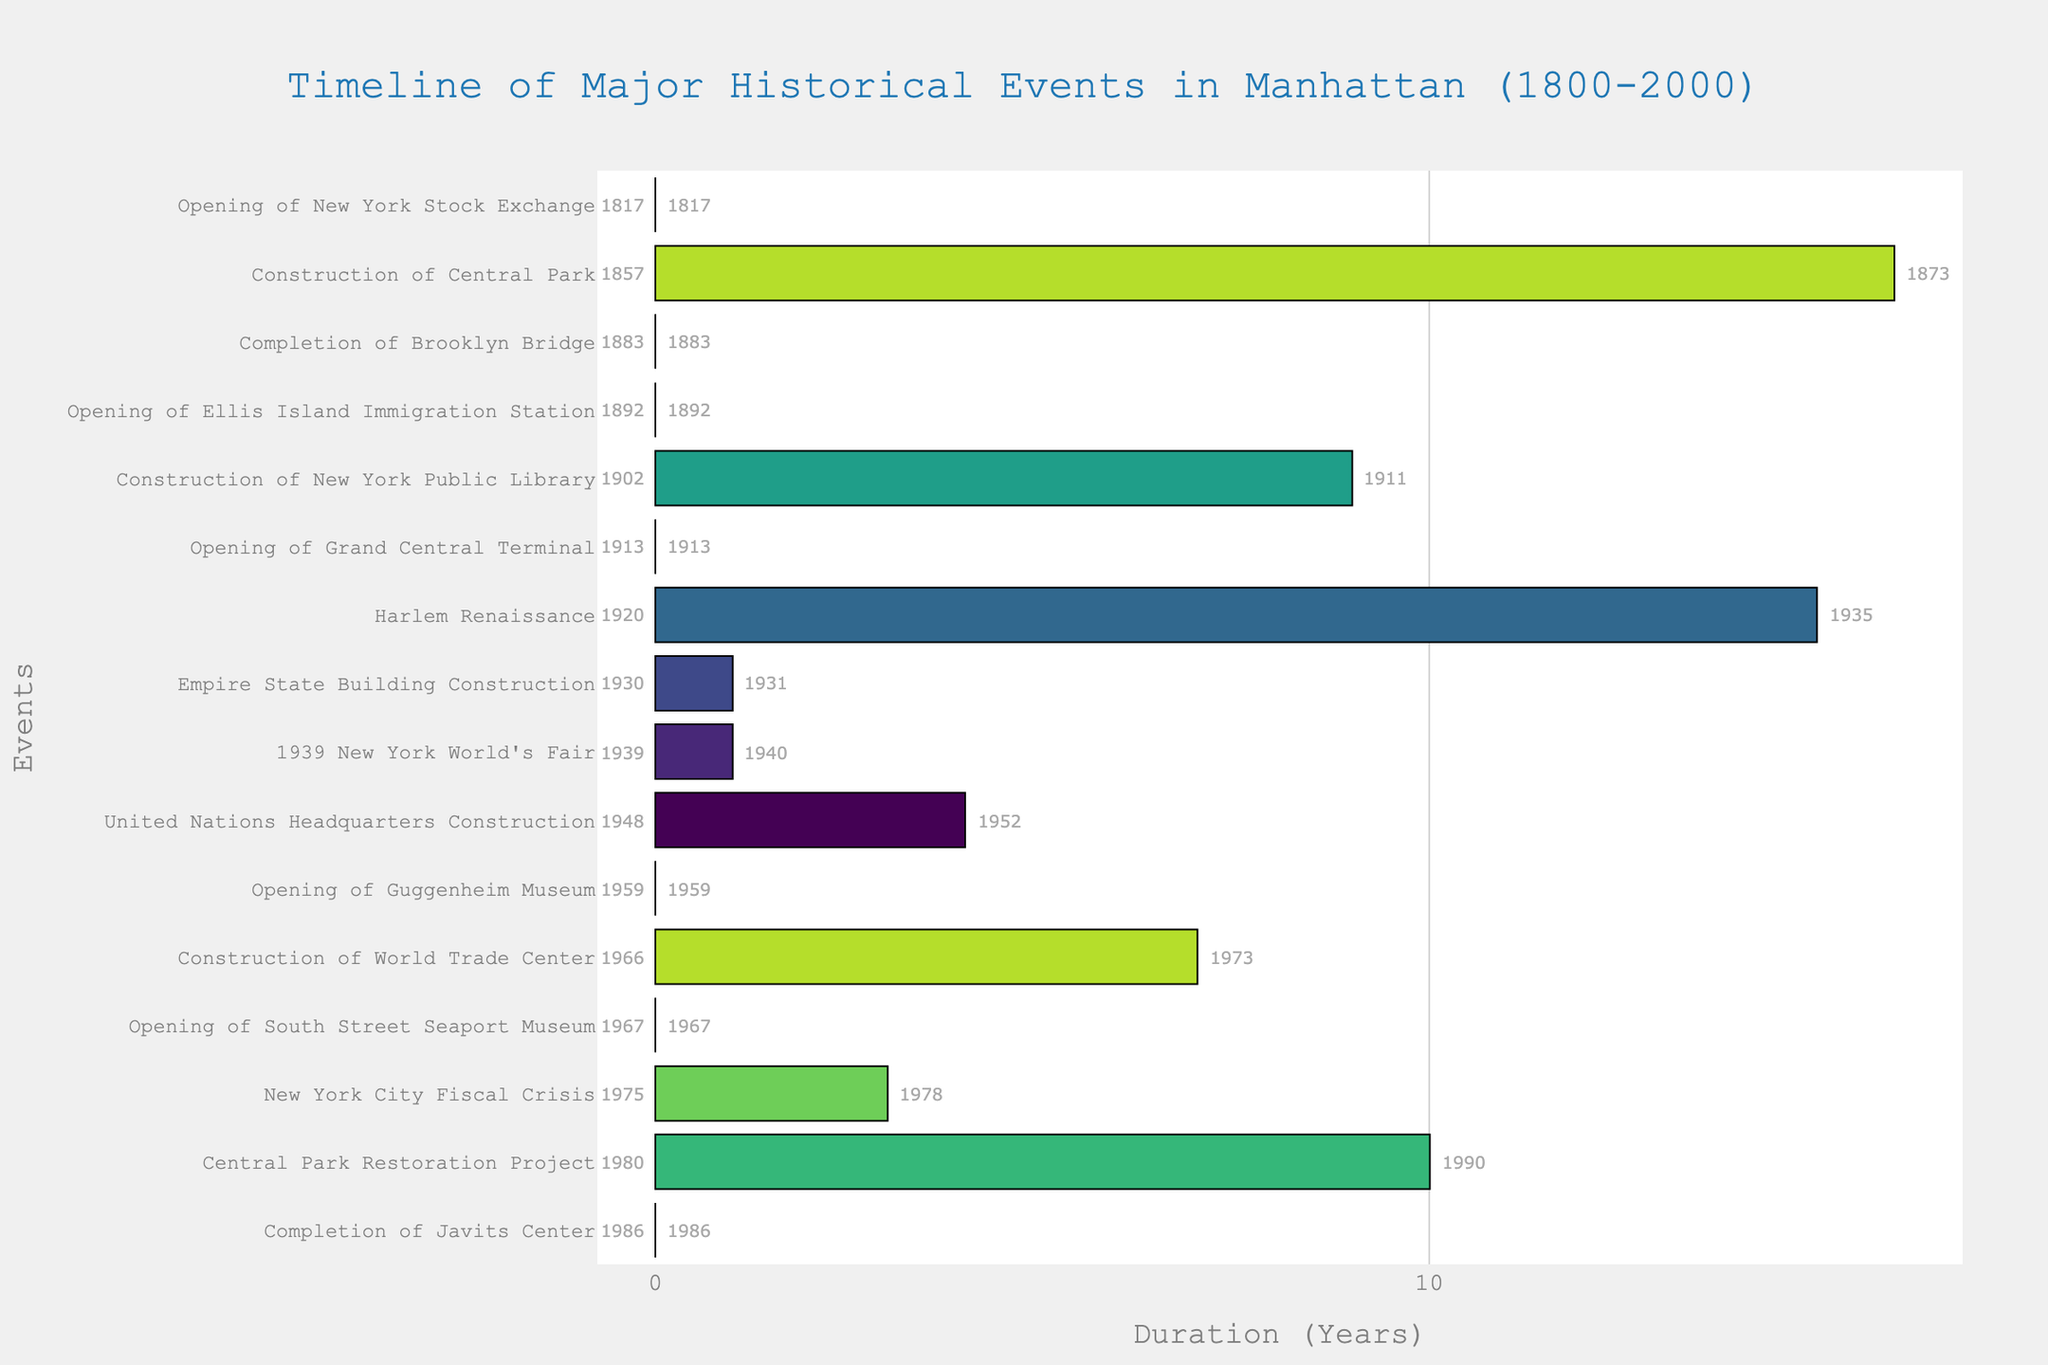Which event began the timeline of major historical events in Manhattan? The first event on the timeline is the one with the earliest "Start" year. In this Gantt Chart, it's the "Opening of New York Stock Exchange" which starts in 1817.
Answer: Opening of New York Stock Exchange How many years did the Construction of Central Park take? To find the duration, subtract the "Start" year from the "End" year. For Central Park, it's from 1857 to 1873, so 1873 - 1857 = 16 years.
Answer: 16 years Which event lasted longest, and how long did it last? To determine the longest event, locate the event with the longest bar. The Central Park Restoration Project, from 1980 to 1990, lasted 10 years.
Answer: Central Park Restoration Project, 10 years Which event marks the end of the historical timeline? The final event on the timeline is the one with the latest "End" year. In this chart, it’s the Central Park Restoration Project ending in 1990.
Answer: Central Park Restoration Project Between the opening of the New York Public Library and the Construction of the United Nations Headquarters, which event started first? The "Start" year of New York Public Library (1902) is earlier than the "Start" year of United Nations Headquarters (1948).
Answer: New York Public Library How many events took place in the 20th century? Check events within the range of 1900-2000 by looking at their "Start" years. The events are New York Public Library, Grand Central Terminal, Harlem Renaissance, Empire State Building, 1939 New York World's Fair, United Nations Headquarters, Guggenheim Museum, World Trade Center, New York City Fiscal Crisis, Central Park Restoration Project, and Completion of Javits Center.
Answer: 11 events Which two events had the shortest duration and how long were they? The shortest bars represent the events with the shortest durations. The "Opening of New York Stock Exchange" and "Completion of Brooklyn Bridge" both lasted 1 year each.
Answer: Opening of New York Stock Exchange and Completion of Brooklyn Bridge, 1 year Compare the Harlem Renaissance and the Empire State Building Construction. Which event lasted longer and by how many years? Harlem Renaissance lasted from 1920 to 1935 (15 years), and Empire State Building Construction lasted from 1930 to 1931 (1 year), so 15 - 1 = 14 years longer.
Answer: Harlem Renaissance, 14 years What was the duration gap between the completion of the World Trade Center and the New York City Fiscal Crisis? The World Trade Center was completed in 1973, and the NYC Fiscal Crisis started in 1975. Subtract the "End" year of World Trade Center from the "Start" year of Fiscal Crisis: 1975 - 1973 = 2 years.
Answer: 2 years 